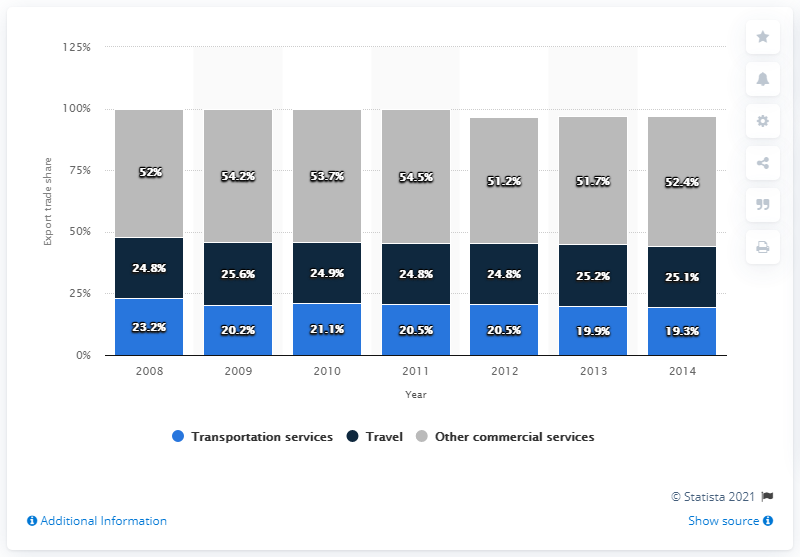Specify some key components in this picture. In 2012, the share of travel services in world export trade was 25.1%. 